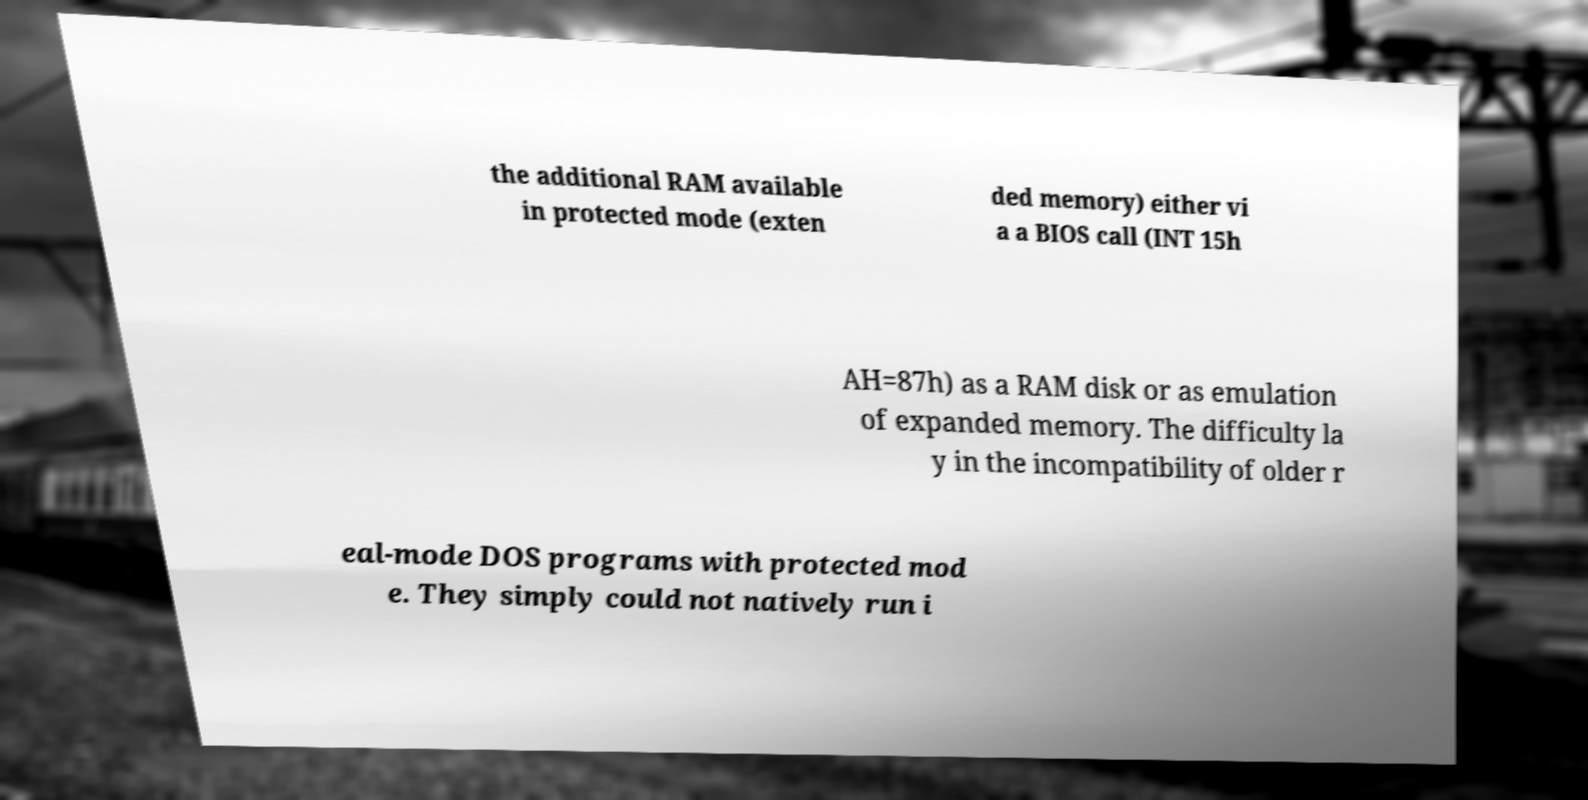There's text embedded in this image that I need extracted. Can you transcribe it verbatim? the additional RAM available in protected mode (exten ded memory) either vi a a BIOS call (INT 15h AH=87h) as a RAM disk or as emulation of expanded memory. The difficulty la y in the incompatibility of older r eal-mode DOS programs with protected mod e. They simply could not natively run i 